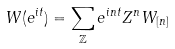<formula> <loc_0><loc_0><loc_500><loc_500>W ( e ^ { i t } ) = \sum _ { \mathbb { Z } } e ^ { i n t } Z ^ { n } W _ { [ n ] }</formula> 